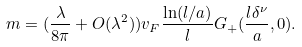<formula> <loc_0><loc_0><loc_500><loc_500>m = ( \frac { \lambda } { 8 \pi } + O ( \lambda ^ { 2 } ) ) v _ { F } \frac { \ln ( l / a ) } { l } G _ { + } ( \frac { l \delta ^ { \nu } } { a } , 0 ) .</formula> 